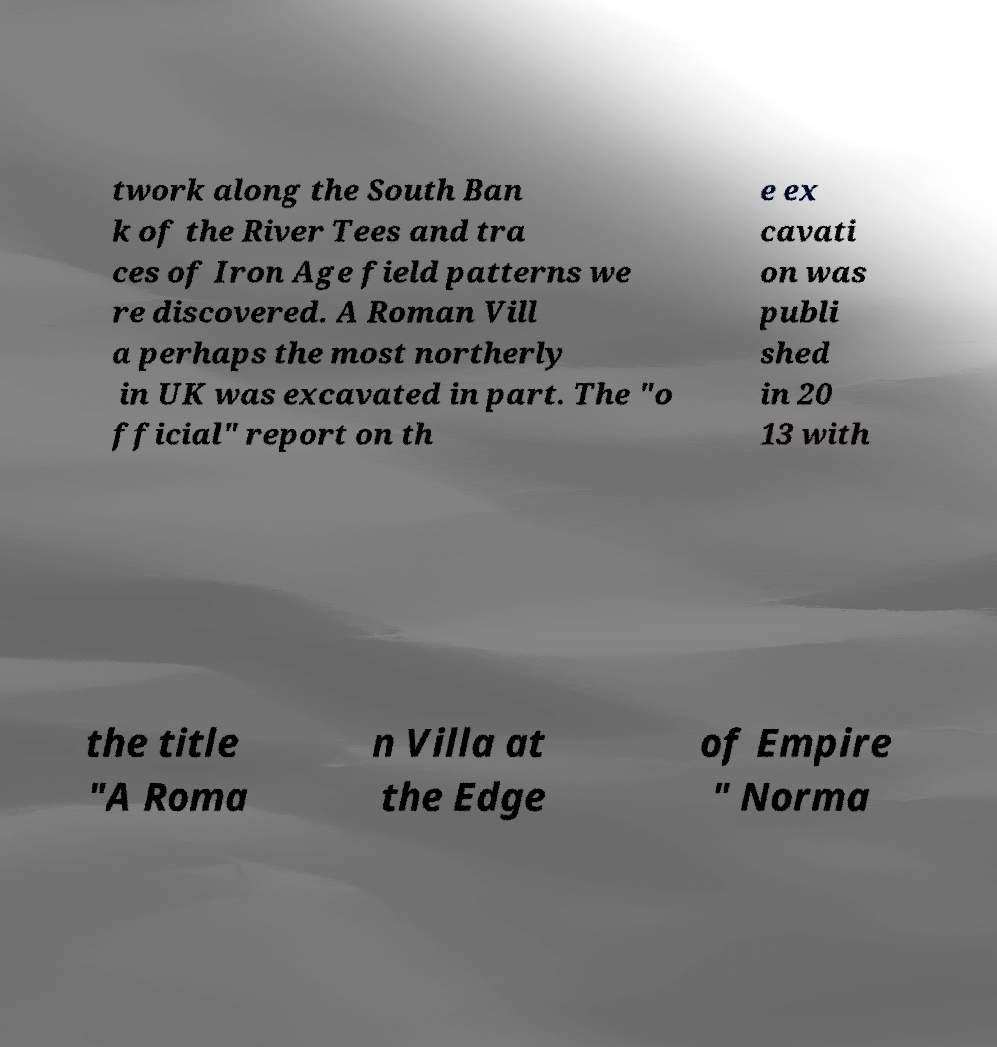Please identify and transcribe the text found in this image. twork along the South Ban k of the River Tees and tra ces of Iron Age field patterns we re discovered. A Roman Vill a perhaps the most northerly in UK was excavated in part. The "o fficial" report on th e ex cavati on was publi shed in 20 13 with the title "A Roma n Villa at the Edge of Empire " Norma 